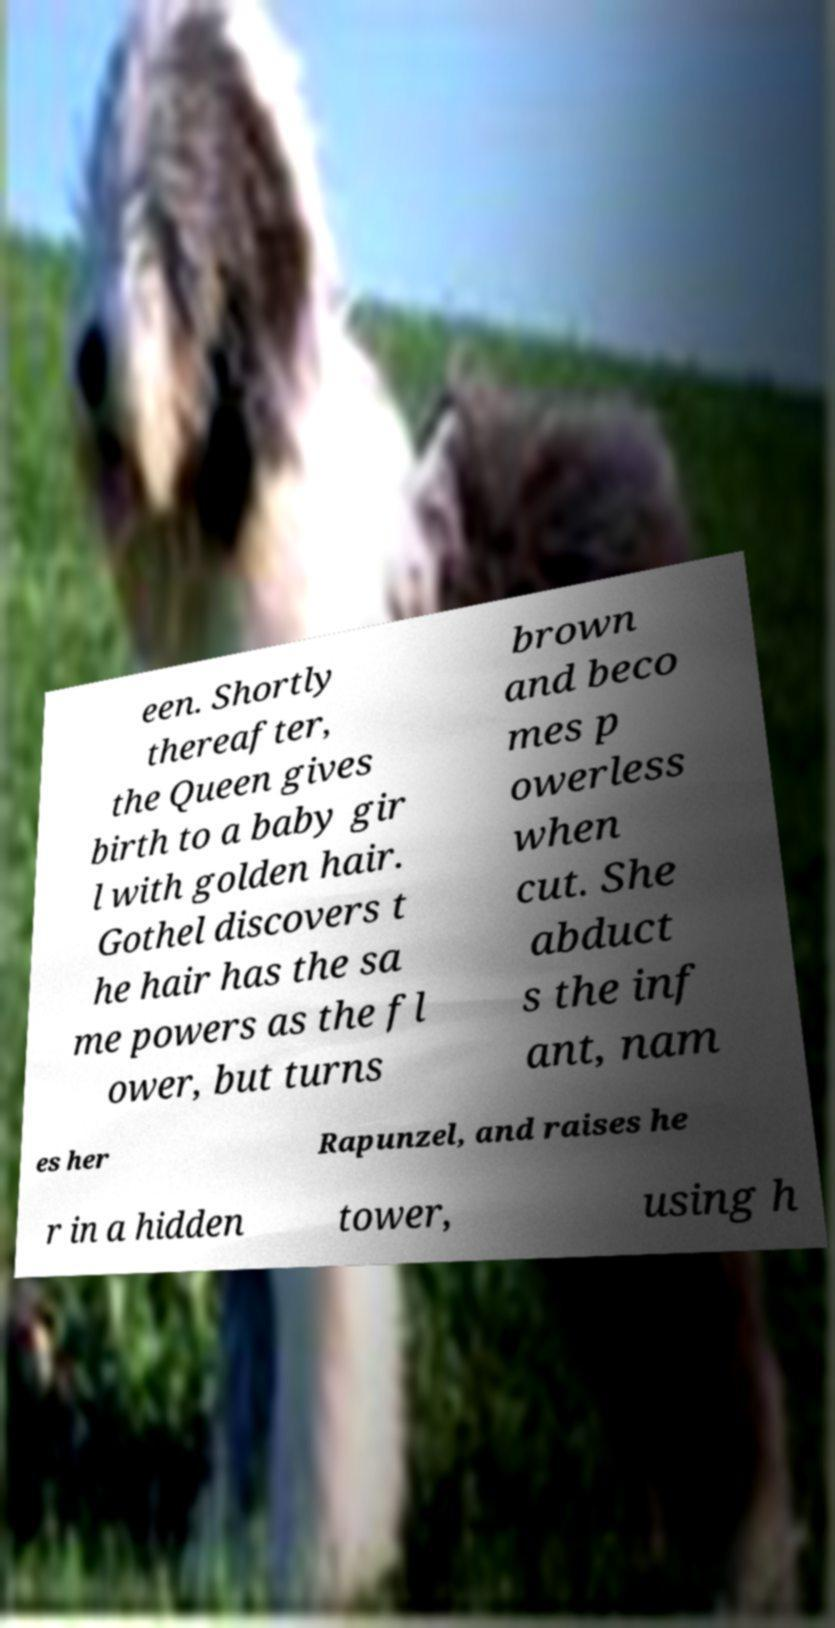There's text embedded in this image that I need extracted. Can you transcribe it verbatim? een. Shortly thereafter, the Queen gives birth to a baby gir l with golden hair. Gothel discovers t he hair has the sa me powers as the fl ower, but turns brown and beco mes p owerless when cut. She abduct s the inf ant, nam es her Rapunzel, and raises he r in a hidden tower, using h 